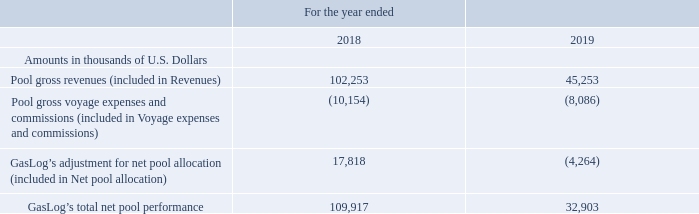Net Pool Allocation: Net pool allocation decreased by $22.1 million, from a positive $17.8 million during the year ended December 31, 2018 to a negative $4.3 million during the year ended December 31, 2019. The decrease in net pool allocation was attributable to the movement in the adjustment of the net pool results generated by the GasLog vessels in accordance with the pool distribution formula for the total fleet of the pool, as well as GasLog’s vessels exiting the Cool Pool in June and July 2019. GasLog recognized gross revenues and gross voyage expenses and commissions of $45.3 million and $8.1 million, respectively, from the operation of its vessels in the Cool Pool during the year ended December 31, 2019 (December 31, 2018: $102.3 million and $10.2 million, respectively). GasLog’s total net pool performance is presented below:
Voyage Expenses and Commissions: Voyage expenses and commissions increased by 16.7%, or $3.4 million, from $20.4 million during the year ended December 31, 2018 to $23.8 million during the year ended December 31, 2019. The increase in voyage expenses and commissions is mainly attributable to an increase of $3.4 million in bunkers and voyage expenses consumed during certain unchartered and off-hire periods for the vessels trading in the spot market.
In which years was the total net pool performance recorded for? 2018, 2019. What accounted for the decrease in net pool allocation? The decrease in net pool allocation was attributable to the movement in the adjustment of the net pool results generated by the gaslog vessels in accordance with the pool distribution formula for the total fleet of the pool, as well as gaslog’s vessels exiting the cool pool in june and july 2019. What accounted for the increase in voyage expenses and commissions? Mainly attributable to an increase of $3.4 million in bunkers and voyage expenses consumed during certain unchartered and off-hire periods for the vessels trading in the spot market. Which year was the pool gross revenues higher? 102,253 > 45,253
Answer: 2018. What is the change in pool gross revenues from 2018 to 2019?
Answer scale should be: thousand. 45,253 - 102,253 
Answer: -57000. What is the percentage change in total net pool performance from 2018 to 2019?
Answer scale should be: percent. (32,903 - 109,917)/109,917 
Answer: -70.07. 